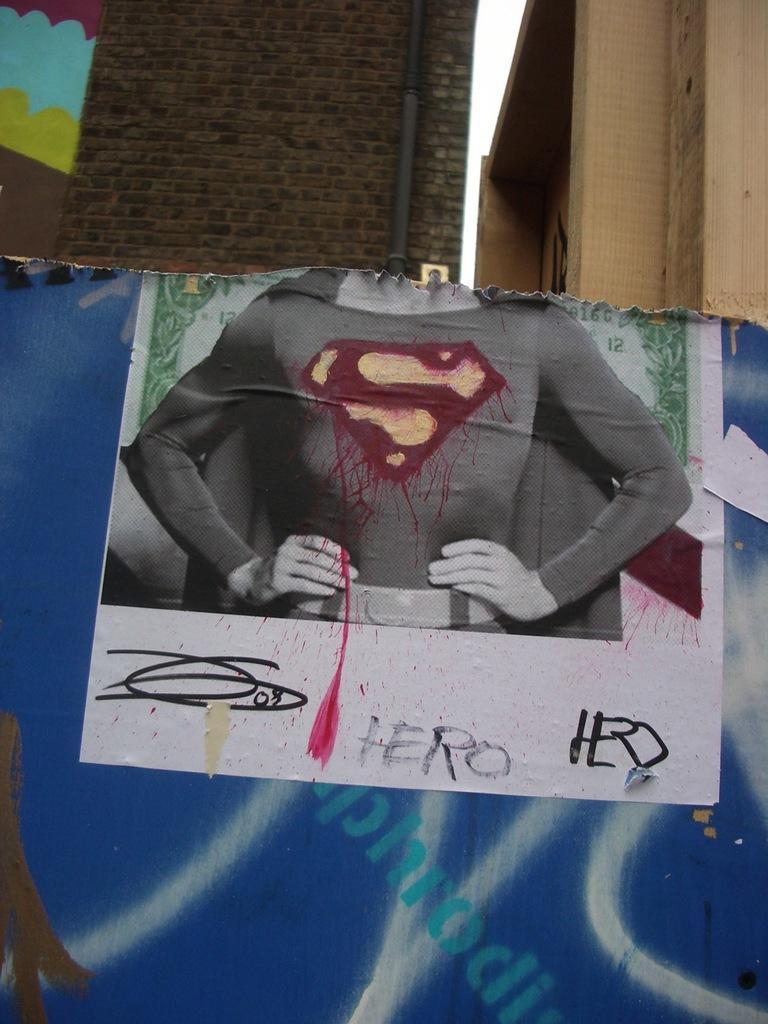How would you summarize this image in a sentence or two? In this image, I can see a poster, buildings, pipe and the sky. This image taken, maybe during a day. 